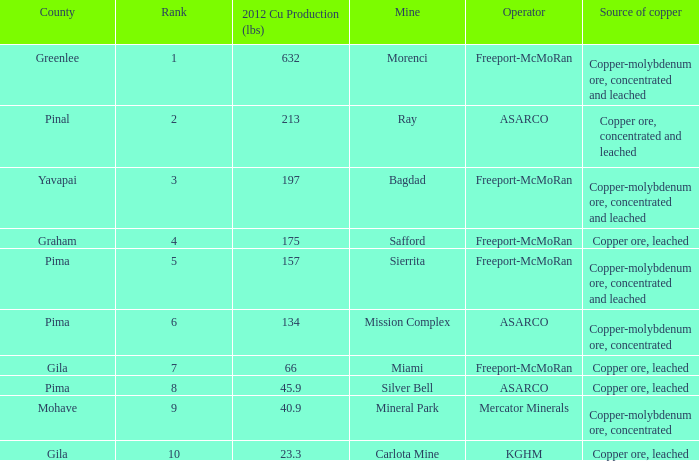Which operator has a rank of 7? Freeport-McMoRan. 